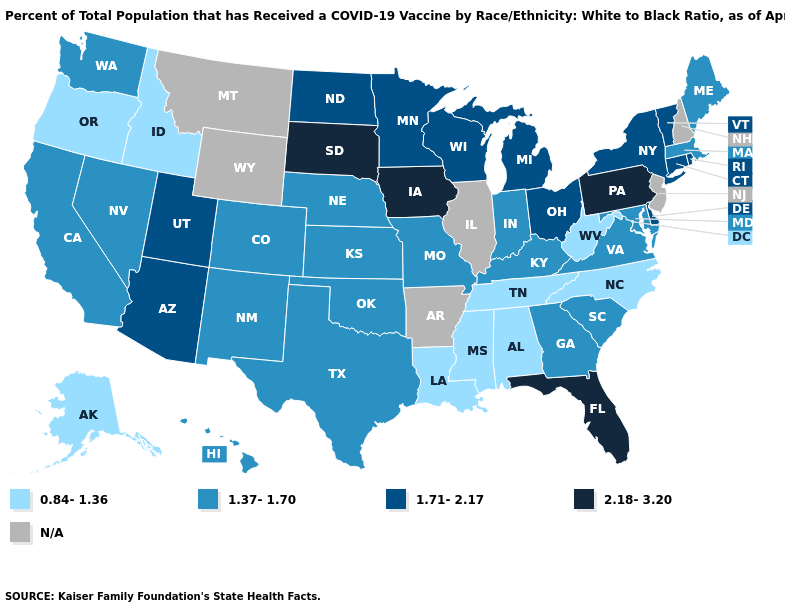What is the lowest value in the USA?
Be succinct. 0.84-1.36. Among the states that border New Jersey , does Pennsylvania have the lowest value?
Be succinct. No. Among the states that border North Dakota , which have the lowest value?
Short answer required. Minnesota. What is the value of Maryland?
Short answer required. 1.37-1.70. Among the states that border New York , does Pennsylvania have the lowest value?
Answer briefly. No. How many symbols are there in the legend?
Be succinct. 5. Does Vermont have the lowest value in the USA?
Answer briefly. No. Name the states that have a value in the range 1.71-2.17?
Give a very brief answer. Arizona, Connecticut, Delaware, Michigan, Minnesota, New York, North Dakota, Ohio, Rhode Island, Utah, Vermont, Wisconsin. Among the states that border Idaho , does Oregon have the lowest value?
Keep it brief. Yes. Name the states that have a value in the range 0.84-1.36?
Keep it brief. Alabama, Alaska, Idaho, Louisiana, Mississippi, North Carolina, Oregon, Tennessee, West Virginia. Among the states that border Indiana , does Kentucky have the highest value?
Concise answer only. No. What is the value of Texas?
Keep it brief. 1.37-1.70. Does New Mexico have the lowest value in the West?
Keep it brief. No. What is the lowest value in the USA?
Answer briefly. 0.84-1.36. 